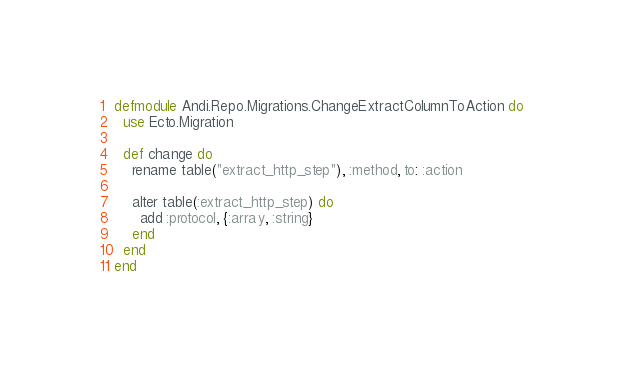<code> <loc_0><loc_0><loc_500><loc_500><_Elixir_>defmodule Andi.Repo.Migrations.ChangeExtractColumnToAction do
  use Ecto.Migration

  def change do
    rename table("extract_http_step"), :method, to: :action

    alter table(:extract_http_step) do
      add :protocol, {:array, :string}
    end
  end
end
</code> 